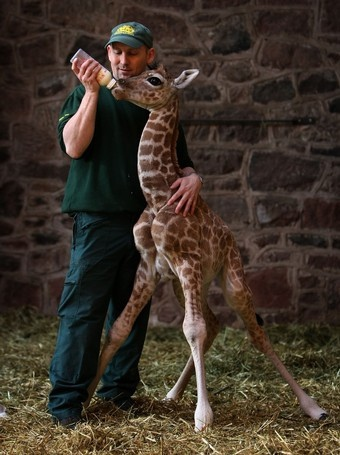Describe the objects in this image and their specific colors. I can see people in black, teal, maroon, and brown tones, giraffe in black, maroon, and gray tones, and bottle in black, brown, tan, and gray tones in this image. 